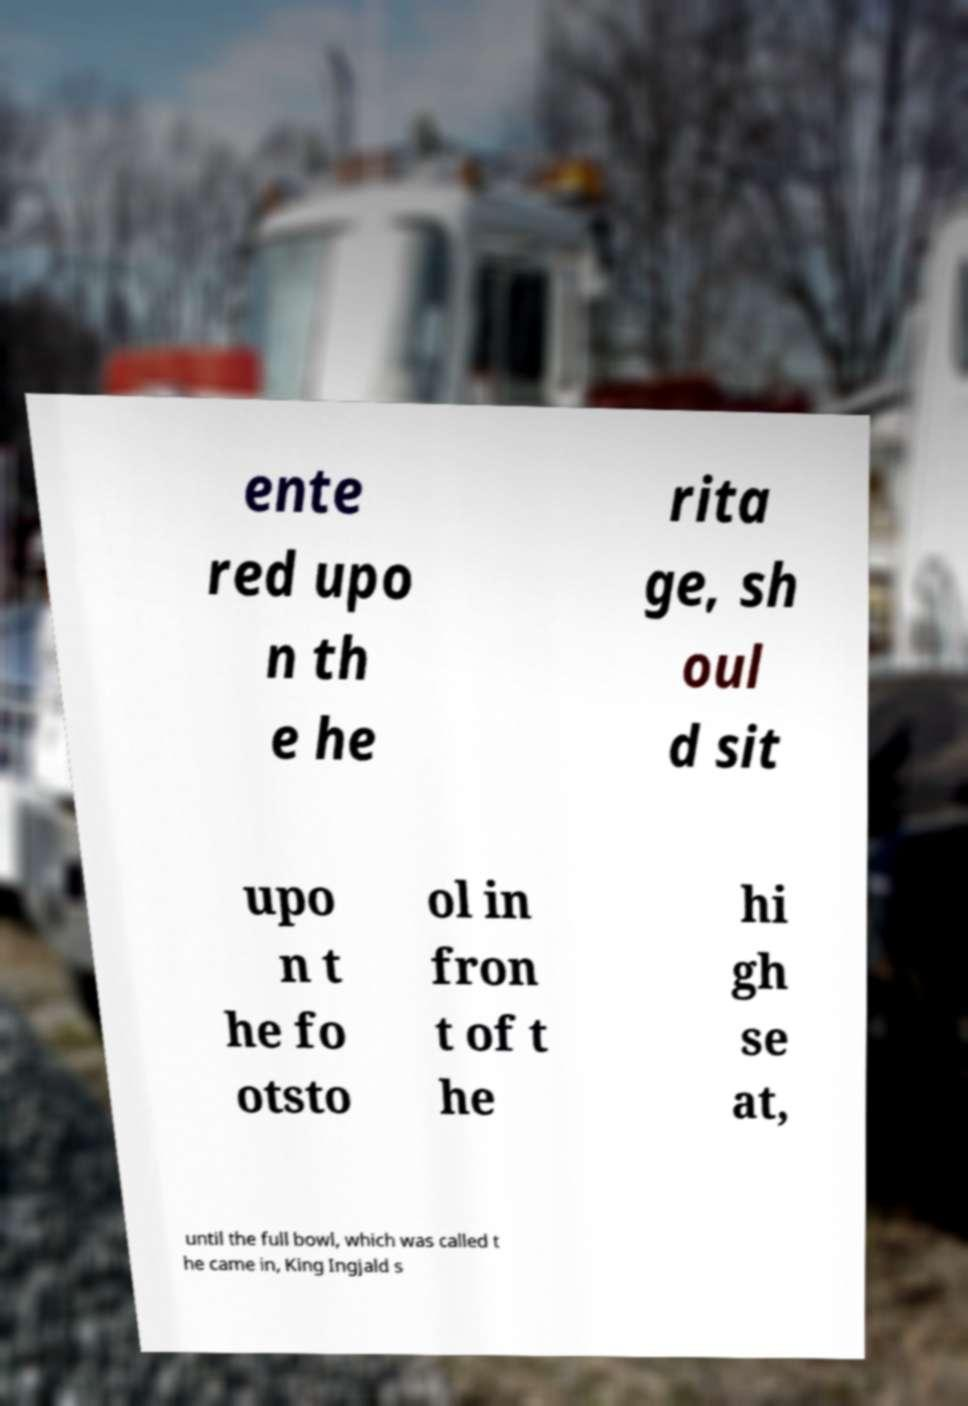For documentation purposes, I need the text within this image transcribed. Could you provide that? ente red upo n th e he rita ge, sh oul d sit upo n t he fo otsto ol in fron t of t he hi gh se at, until the full bowl, which was called t he came in, King Ingjald s 